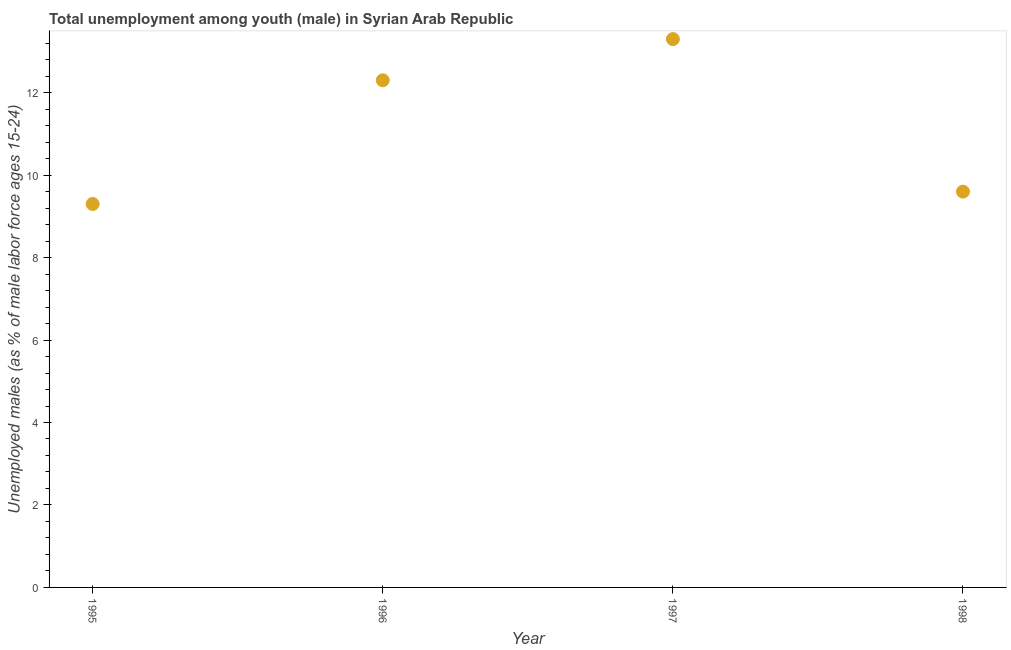What is the unemployed male youth population in 1995?
Offer a terse response. 9.3. Across all years, what is the maximum unemployed male youth population?
Give a very brief answer. 13.3. Across all years, what is the minimum unemployed male youth population?
Keep it short and to the point. 9.3. In which year was the unemployed male youth population maximum?
Give a very brief answer. 1997. In which year was the unemployed male youth population minimum?
Provide a succinct answer. 1995. What is the sum of the unemployed male youth population?
Keep it short and to the point. 44.5. What is the difference between the unemployed male youth population in 1995 and 1998?
Give a very brief answer. -0.3. What is the average unemployed male youth population per year?
Provide a succinct answer. 11.13. What is the median unemployed male youth population?
Provide a succinct answer. 10.95. In how many years, is the unemployed male youth population greater than 8 %?
Offer a very short reply. 4. What is the ratio of the unemployed male youth population in 1995 to that in 1996?
Offer a very short reply. 0.76. Is the unemployed male youth population in 1995 less than that in 1998?
Your answer should be compact. Yes. Is the sum of the unemployed male youth population in 1996 and 1998 greater than the maximum unemployed male youth population across all years?
Ensure brevity in your answer.  Yes. What is the difference between the highest and the lowest unemployed male youth population?
Keep it short and to the point. 4. Does the unemployed male youth population monotonically increase over the years?
Your answer should be very brief. No. Are the values on the major ticks of Y-axis written in scientific E-notation?
Your answer should be very brief. No. What is the title of the graph?
Offer a very short reply. Total unemployment among youth (male) in Syrian Arab Republic. What is the label or title of the Y-axis?
Offer a terse response. Unemployed males (as % of male labor force ages 15-24). What is the Unemployed males (as % of male labor force ages 15-24) in 1995?
Your answer should be compact. 9.3. What is the Unemployed males (as % of male labor force ages 15-24) in 1996?
Offer a terse response. 12.3. What is the Unemployed males (as % of male labor force ages 15-24) in 1997?
Give a very brief answer. 13.3. What is the Unemployed males (as % of male labor force ages 15-24) in 1998?
Make the answer very short. 9.6. What is the difference between the Unemployed males (as % of male labor force ages 15-24) in 1996 and 1998?
Offer a terse response. 2.7. What is the ratio of the Unemployed males (as % of male labor force ages 15-24) in 1995 to that in 1996?
Ensure brevity in your answer.  0.76. What is the ratio of the Unemployed males (as % of male labor force ages 15-24) in 1995 to that in 1997?
Offer a terse response. 0.7. What is the ratio of the Unemployed males (as % of male labor force ages 15-24) in 1996 to that in 1997?
Your response must be concise. 0.93. What is the ratio of the Unemployed males (as % of male labor force ages 15-24) in 1996 to that in 1998?
Provide a succinct answer. 1.28. What is the ratio of the Unemployed males (as % of male labor force ages 15-24) in 1997 to that in 1998?
Provide a succinct answer. 1.39. 